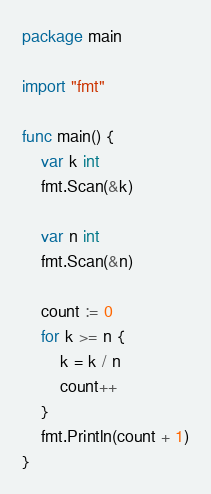<code> <loc_0><loc_0><loc_500><loc_500><_Go_>package main

import "fmt"

func main() {
	var k int
	fmt.Scan(&k)

	var n int
	fmt.Scan(&n)

	count := 0
	for k >= n {
		k = k / n
		count++
	}
	fmt.Println(count + 1)
}
</code> 